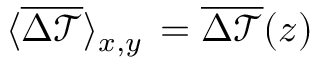Convert formula to latex. <formula><loc_0><loc_0><loc_500><loc_500>\langle \overline { { \Delta \mathcal { T } } } \rangle _ { x , y } \, = \overline { { \Delta \mathcal { T } } } ( z )</formula> 